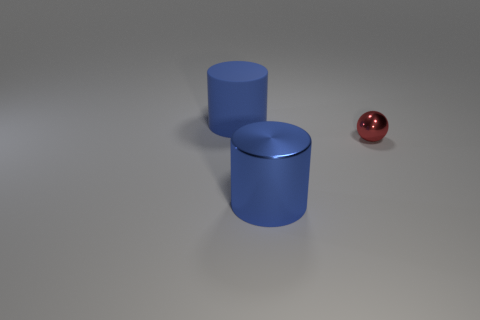Subtract all cylinders. How many objects are left? 1 Add 3 tiny green shiny cubes. How many objects exist? 6 Add 3 tiny red metal balls. How many tiny red metal balls exist? 4 Subtract 0 brown spheres. How many objects are left? 3 Subtract all blue things. Subtract all tiny purple rubber cylinders. How many objects are left? 1 Add 1 big matte cylinders. How many big matte cylinders are left? 2 